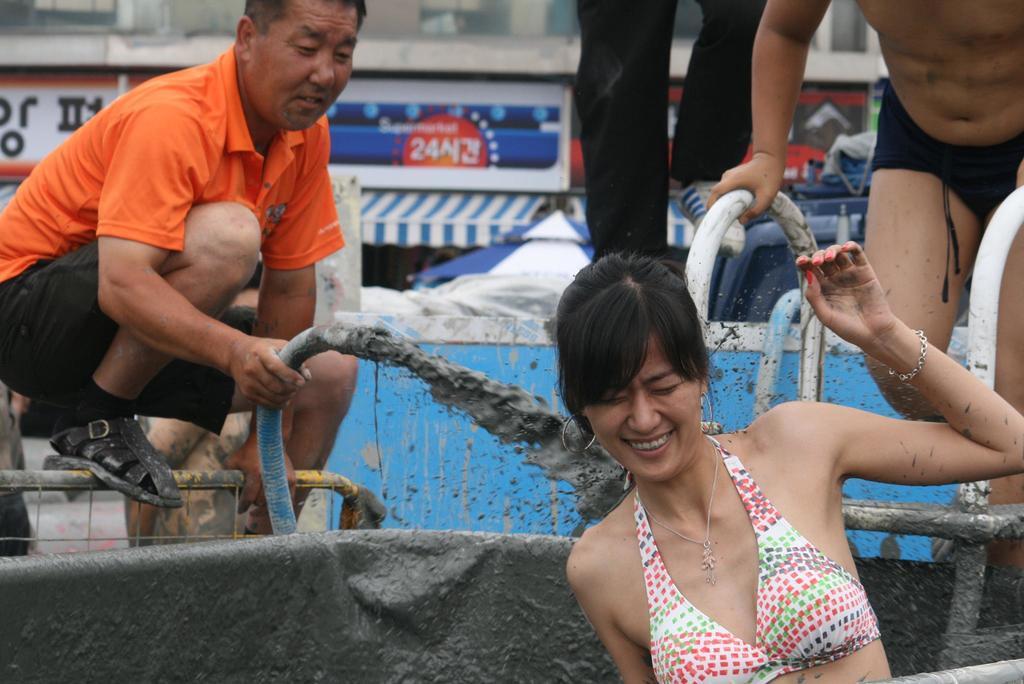Describe this image in one or two sentences. In this image, we can see persons wearing clothes. There are two persons holding pipes with their hands. 